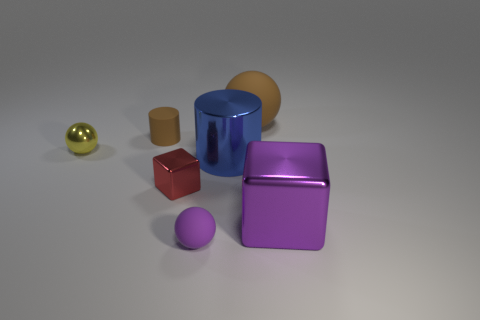There is a small ball that is right of the small yellow metallic ball; how many matte things are left of it?
Your response must be concise. 1. Is the color of the big ball that is to the right of the small brown matte thing the same as the large cylinder?
Your answer should be compact. No. How many objects are either large purple metal blocks or large things behind the tiny metal sphere?
Ensure brevity in your answer.  2. Is the shape of the tiny rubber thing behind the small red metallic object the same as the small metallic object to the right of the yellow ball?
Provide a succinct answer. No. Is there any other thing that has the same color as the big metallic block?
Your answer should be very brief. Yes. What is the shape of the tiny red object that is made of the same material as the tiny yellow ball?
Provide a short and direct response. Cube. What is the material of the object that is both to the right of the large cylinder and on the left side of the large metallic block?
Give a very brief answer. Rubber. Is there any other thing that is the same size as the red block?
Your answer should be very brief. Yes. Does the large ball have the same color as the small metal cube?
Provide a short and direct response. No. What is the shape of the tiny matte object that is the same color as the big block?
Your answer should be compact. Sphere. 